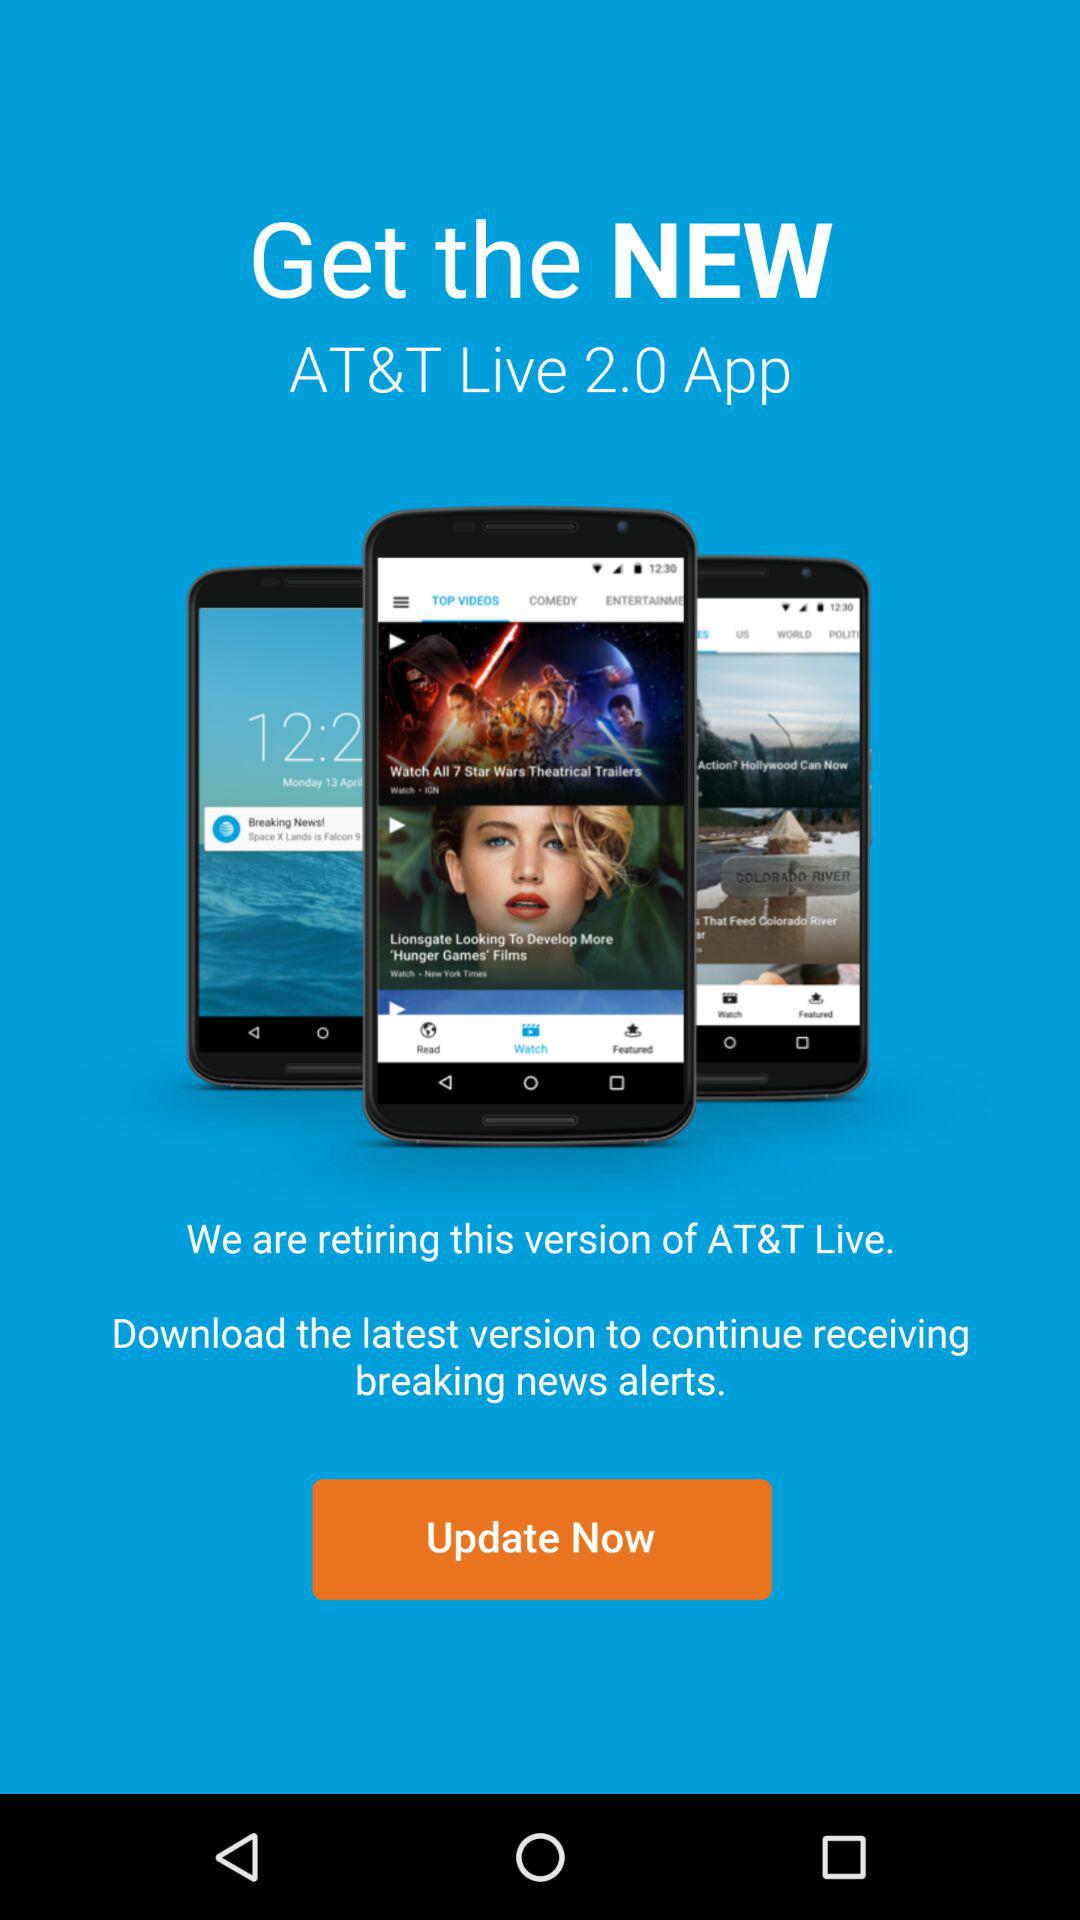What is the new version?
When the provided information is insufficient, respond with <no answer>. <no answer> 